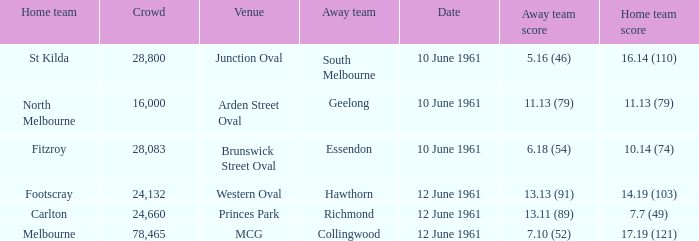Help me parse the entirety of this table. {'header': ['Home team', 'Crowd', 'Venue', 'Away team', 'Date', 'Away team score', 'Home team score'], 'rows': [['St Kilda', '28,800', 'Junction Oval', 'South Melbourne', '10 June 1961', '5.16 (46)', '16.14 (110)'], ['North Melbourne', '16,000', 'Arden Street Oval', 'Geelong', '10 June 1961', '11.13 (79)', '11.13 (79)'], ['Fitzroy', '28,083', 'Brunswick Street Oval', 'Essendon', '10 June 1961', '6.18 (54)', '10.14 (74)'], ['Footscray', '24,132', 'Western Oval', 'Hawthorn', '12 June 1961', '13.13 (91)', '14.19 (103)'], ['Carlton', '24,660', 'Princes Park', 'Richmond', '12 June 1961', '13.11 (89)', '7.7 (49)'], ['Melbourne', '78,465', 'MCG', 'Collingwood', '12 June 1961', '7.10 (52)', '17.19 (121)']]} What was the home team score for the Richmond away team? 7.7 (49). 